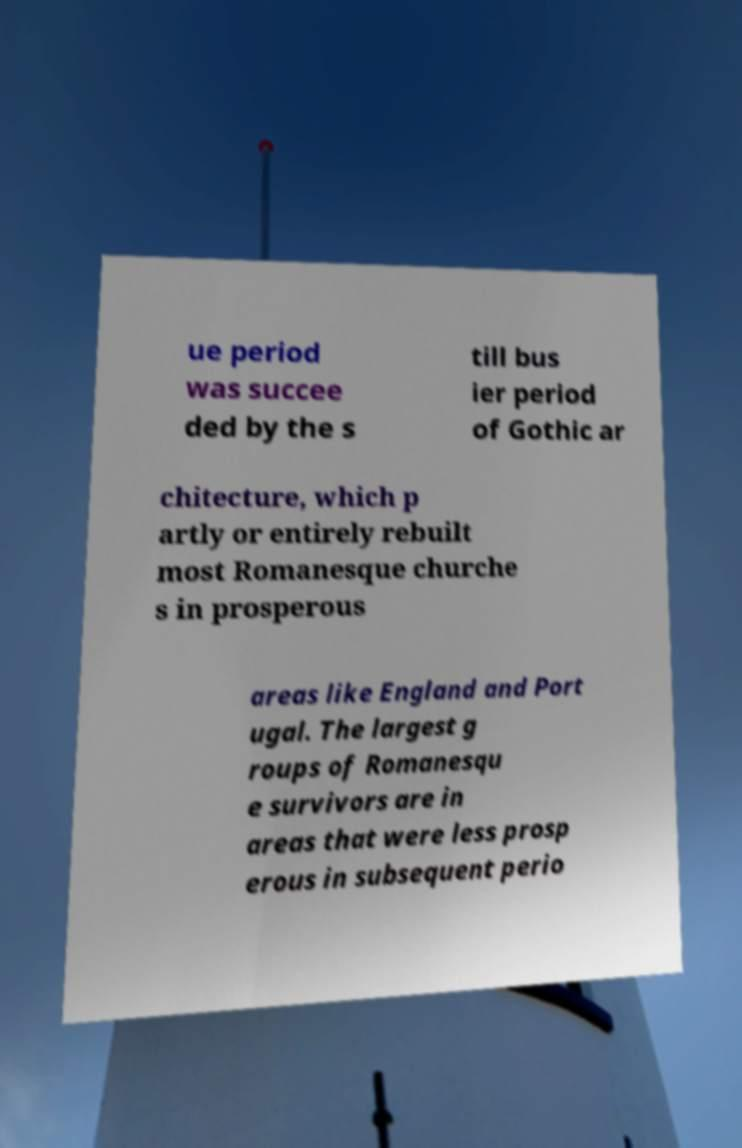Could you assist in decoding the text presented in this image and type it out clearly? ue period was succee ded by the s till bus ier period of Gothic ar chitecture, which p artly or entirely rebuilt most Romanesque churche s in prosperous areas like England and Port ugal. The largest g roups of Romanesqu e survivors are in areas that were less prosp erous in subsequent perio 